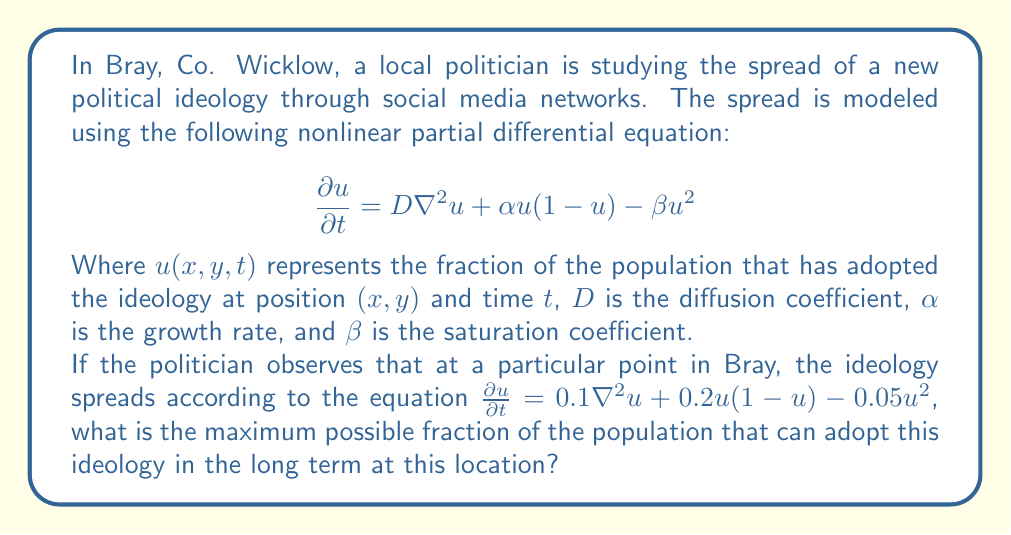Teach me how to tackle this problem. To solve this problem, we need to follow these steps:

1) First, we identify that the equation given is in the form of our model:

   $$\frac{\partial u}{\partial t} = D\nabla^2u + \alpha u(1-u) - \beta u^2$$

   Where $D = 0.1$, $\alpha = 0.2$, and $\beta = 0.05$.

2) In the long term, we expect the system to reach a steady state, where $\frac{\partial u}{\partial t} = 0$ and $\nabla^2u = 0$ (assuming spatial homogeneity at equilibrium).

3) Setting $\frac{\partial u}{\partial t} = 0$ and $\nabla^2u = 0$ in our equation:

   $$0 = 0.2u(1-u) - 0.05u^2$$

4) Factoring out $u$:

   $$0 = u(0.2 - 0.2u - 0.05u)$$
   $$0 = u(0.2 - 0.25u)$$

5) This equation has two solutions:
   
   $u = 0$ (trivial solution)
   $0.2 - 0.25u = 0$

6) Solving the second equation:

   $$0.25u = 0.2$$
   $$u = 0.8$$

7) The non-zero solution $u = 0.8$ represents the maximum fraction of the population that can adopt the ideology in the long term.

This solution makes sense in the context of the problem. The ideology spreads (represented by the positive growth term $\alpha u(1-u)$) but its growth is limited by the negative term $-\beta u^2$, leading to a stable non-zero equilibrium.
Answer: The maximum possible fraction of the population that can adopt this ideology in the long term at this location is 0.8 or 80%. 